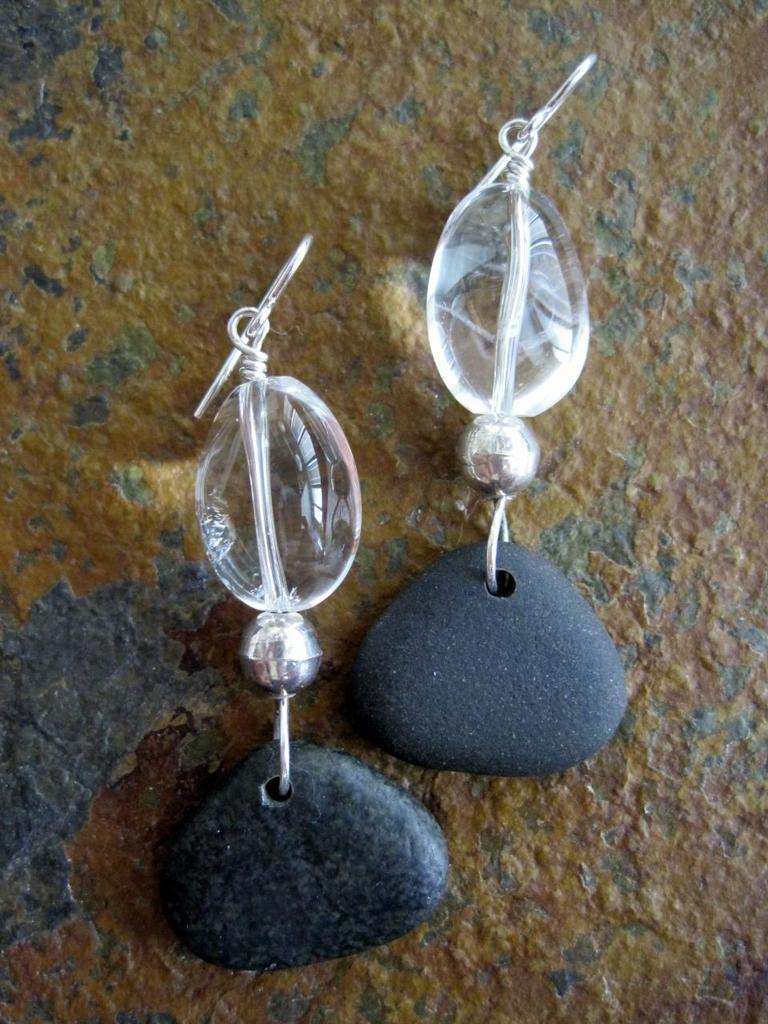What type of accessory is visible in the image? There are earrings in the image. Where are the earrings located? The earrings are on a surface. What type of shade is provided by the oranges in the image? There are no oranges present in the image, so no shade can be provided by them. 